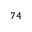<formula> <loc_0><loc_0><loc_500><loc_500>^ { 7 4 }</formula> 